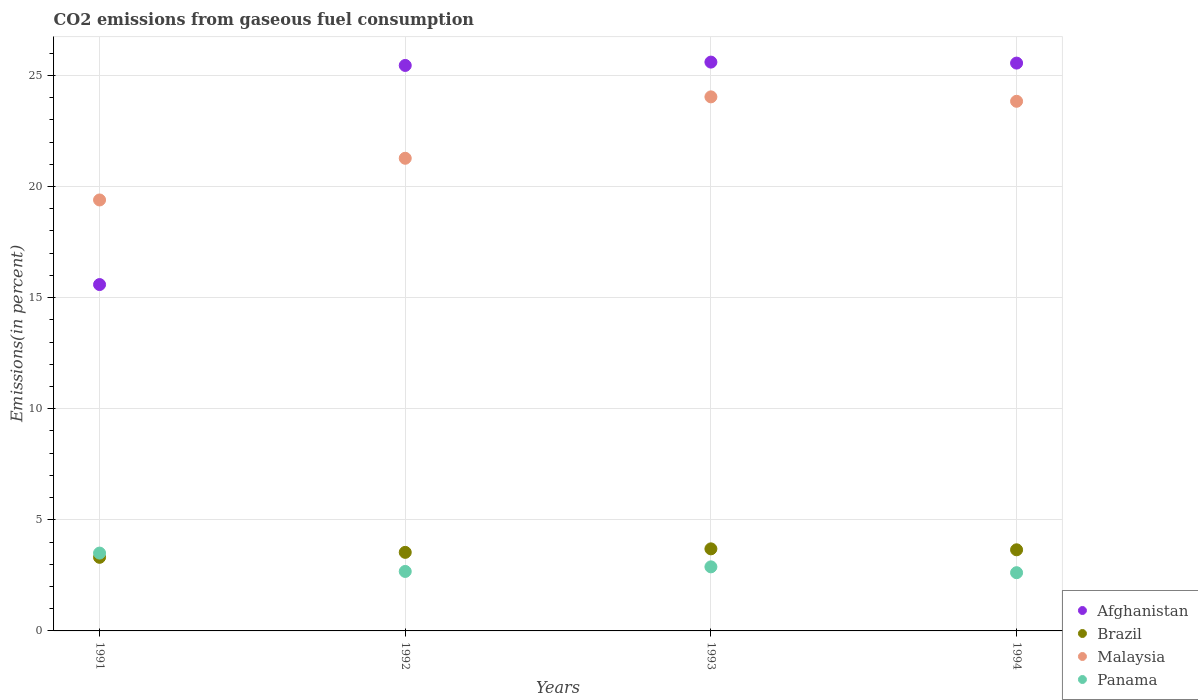What is the total CO2 emitted in Malaysia in 1993?
Offer a very short reply. 24.04. Across all years, what is the maximum total CO2 emitted in Afghanistan?
Offer a very short reply. 25.6. Across all years, what is the minimum total CO2 emitted in Malaysia?
Offer a terse response. 19.4. In which year was the total CO2 emitted in Afghanistan maximum?
Your answer should be compact. 1993. What is the total total CO2 emitted in Afghanistan in the graph?
Your response must be concise. 92.19. What is the difference between the total CO2 emitted in Malaysia in 1992 and that in 1994?
Keep it short and to the point. -2.56. What is the difference between the total CO2 emitted in Panama in 1993 and the total CO2 emitted in Brazil in 1991?
Provide a succinct answer. -0.43. What is the average total CO2 emitted in Malaysia per year?
Your response must be concise. 22.14. In the year 1994, what is the difference between the total CO2 emitted in Malaysia and total CO2 emitted in Brazil?
Offer a very short reply. 20.19. What is the ratio of the total CO2 emitted in Panama in 1992 to that in 1994?
Provide a succinct answer. 1.02. What is the difference between the highest and the second highest total CO2 emitted in Malaysia?
Keep it short and to the point. 0.2. What is the difference between the highest and the lowest total CO2 emitted in Malaysia?
Your answer should be compact. 4.64. In how many years, is the total CO2 emitted in Panama greater than the average total CO2 emitted in Panama taken over all years?
Give a very brief answer. 1. Is it the case that in every year, the sum of the total CO2 emitted in Panama and total CO2 emitted in Afghanistan  is greater than the sum of total CO2 emitted in Malaysia and total CO2 emitted in Brazil?
Provide a short and direct response. Yes. Is it the case that in every year, the sum of the total CO2 emitted in Brazil and total CO2 emitted in Afghanistan  is greater than the total CO2 emitted in Panama?
Make the answer very short. Yes. Is the total CO2 emitted in Panama strictly greater than the total CO2 emitted in Brazil over the years?
Keep it short and to the point. No. Is the total CO2 emitted in Panama strictly less than the total CO2 emitted in Malaysia over the years?
Your answer should be compact. Yes. How many dotlines are there?
Keep it short and to the point. 4. Where does the legend appear in the graph?
Provide a short and direct response. Bottom right. How many legend labels are there?
Provide a succinct answer. 4. How are the legend labels stacked?
Your answer should be very brief. Vertical. What is the title of the graph?
Make the answer very short. CO2 emissions from gaseous fuel consumption. Does "Belize" appear as one of the legend labels in the graph?
Your response must be concise. No. What is the label or title of the Y-axis?
Provide a short and direct response. Emissions(in percent). What is the Emissions(in percent) of Afghanistan in 1991?
Your response must be concise. 15.59. What is the Emissions(in percent) of Brazil in 1991?
Offer a very short reply. 3.31. What is the Emissions(in percent) in Malaysia in 1991?
Offer a terse response. 19.4. What is the Emissions(in percent) in Panama in 1991?
Offer a terse response. 3.5. What is the Emissions(in percent) of Afghanistan in 1992?
Your response must be concise. 25.45. What is the Emissions(in percent) in Brazil in 1992?
Offer a very short reply. 3.54. What is the Emissions(in percent) of Malaysia in 1992?
Provide a short and direct response. 21.27. What is the Emissions(in percent) of Panama in 1992?
Your answer should be compact. 2.68. What is the Emissions(in percent) in Afghanistan in 1993?
Give a very brief answer. 25.6. What is the Emissions(in percent) in Brazil in 1993?
Offer a terse response. 3.69. What is the Emissions(in percent) in Malaysia in 1993?
Make the answer very short. 24.04. What is the Emissions(in percent) in Panama in 1993?
Provide a succinct answer. 2.88. What is the Emissions(in percent) of Afghanistan in 1994?
Ensure brevity in your answer.  25.56. What is the Emissions(in percent) of Brazil in 1994?
Make the answer very short. 3.65. What is the Emissions(in percent) of Malaysia in 1994?
Your answer should be compact. 23.84. What is the Emissions(in percent) of Panama in 1994?
Your answer should be very brief. 2.62. Across all years, what is the maximum Emissions(in percent) of Afghanistan?
Give a very brief answer. 25.6. Across all years, what is the maximum Emissions(in percent) in Brazil?
Keep it short and to the point. 3.69. Across all years, what is the maximum Emissions(in percent) of Malaysia?
Your answer should be very brief. 24.04. Across all years, what is the maximum Emissions(in percent) of Panama?
Provide a short and direct response. 3.5. Across all years, what is the minimum Emissions(in percent) in Afghanistan?
Make the answer very short. 15.59. Across all years, what is the minimum Emissions(in percent) of Brazil?
Your response must be concise. 3.31. Across all years, what is the minimum Emissions(in percent) in Malaysia?
Your answer should be compact. 19.4. Across all years, what is the minimum Emissions(in percent) in Panama?
Offer a terse response. 2.62. What is the total Emissions(in percent) of Afghanistan in the graph?
Provide a short and direct response. 92.19. What is the total Emissions(in percent) of Brazil in the graph?
Keep it short and to the point. 14.19. What is the total Emissions(in percent) in Malaysia in the graph?
Provide a succinct answer. 88.54. What is the total Emissions(in percent) in Panama in the graph?
Offer a terse response. 11.68. What is the difference between the Emissions(in percent) in Afghanistan in 1991 and that in 1992?
Keep it short and to the point. -9.86. What is the difference between the Emissions(in percent) of Brazil in 1991 and that in 1992?
Offer a very short reply. -0.22. What is the difference between the Emissions(in percent) in Malaysia in 1991 and that in 1992?
Provide a succinct answer. -1.88. What is the difference between the Emissions(in percent) of Panama in 1991 and that in 1992?
Offer a very short reply. 0.83. What is the difference between the Emissions(in percent) of Afghanistan in 1991 and that in 1993?
Keep it short and to the point. -10.01. What is the difference between the Emissions(in percent) in Brazil in 1991 and that in 1993?
Offer a terse response. -0.38. What is the difference between the Emissions(in percent) in Malaysia in 1991 and that in 1993?
Offer a very short reply. -4.64. What is the difference between the Emissions(in percent) of Panama in 1991 and that in 1993?
Provide a succinct answer. 0.62. What is the difference between the Emissions(in percent) of Afghanistan in 1991 and that in 1994?
Provide a succinct answer. -9.97. What is the difference between the Emissions(in percent) of Brazil in 1991 and that in 1994?
Ensure brevity in your answer.  -0.34. What is the difference between the Emissions(in percent) in Malaysia in 1991 and that in 1994?
Keep it short and to the point. -4.44. What is the difference between the Emissions(in percent) in Panama in 1991 and that in 1994?
Give a very brief answer. 0.88. What is the difference between the Emissions(in percent) of Afghanistan in 1992 and that in 1993?
Your answer should be very brief. -0.15. What is the difference between the Emissions(in percent) of Brazil in 1992 and that in 1993?
Give a very brief answer. -0.16. What is the difference between the Emissions(in percent) of Malaysia in 1992 and that in 1993?
Your answer should be compact. -2.76. What is the difference between the Emissions(in percent) in Panama in 1992 and that in 1993?
Your answer should be compact. -0.21. What is the difference between the Emissions(in percent) of Afghanistan in 1992 and that in 1994?
Offer a terse response. -0.11. What is the difference between the Emissions(in percent) of Brazil in 1992 and that in 1994?
Offer a very short reply. -0.12. What is the difference between the Emissions(in percent) in Malaysia in 1992 and that in 1994?
Keep it short and to the point. -2.56. What is the difference between the Emissions(in percent) in Panama in 1992 and that in 1994?
Your answer should be very brief. 0.06. What is the difference between the Emissions(in percent) of Afghanistan in 1993 and that in 1994?
Provide a short and direct response. 0.04. What is the difference between the Emissions(in percent) in Brazil in 1993 and that in 1994?
Your answer should be very brief. 0.04. What is the difference between the Emissions(in percent) in Malaysia in 1993 and that in 1994?
Offer a terse response. 0.2. What is the difference between the Emissions(in percent) in Panama in 1993 and that in 1994?
Provide a short and direct response. 0.26. What is the difference between the Emissions(in percent) in Afghanistan in 1991 and the Emissions(in percent) in Brazil in 1992?
Make the answer very short. 12.05. What is the difference between the Emissions(in percent) of Afghanistan in 1991 and the Emissions(in percent) of Malaysia in 1992?
Ensure brevity in your answer.  -5.68. What is the difference between the Emissions(in percent) in Afghanistan in 1991 and the Emissions(in percent) in Panama in 1992?
Offer a very short reply. 12.91. What is the difference between the Emissions(in percent) in Brazil in 1991 and the Emissions(in percent) in Malaysia in 1992?
Make the answer very short. -17.96. What is the difference between the Emissions(in percent) of Brazil in 1991 and the Emissions(in percent) of Panama in 1992?
Your answer should be compact. 0.64. What is the difference between the Emissions(in percent) in Malaysia in 1991 and the Emissions(in percent) in Panama in 1992?
Give a very brief answer. 16.72. What is the difference between the Emissions(in percent) of Afghanistan in 1991 and the Emissions(in percent) of Brazil in 1993?
Ensure brevity in your answer.  11.89. What is the difference between the Emissions(in percent) of Afghanistan in 1991 and the Emissions(in percent) of Malaysia in 1993?
Provide a succinct answer. -8.45. What is the difference between the Emissions(in percent) of Afghanistan in 1991 and the Emissions(in percent) of Panama in 1993?
Your answer should be very brief. 12.7. What is the difference between the Emissions(in percent) in Brazil in 1991 and the Emissions(in percent) in Malaysia in 1993?
Make the answer very short. -20.72. What is the difference between the Emissions(in percent) in Brazil in 1991 and the Emissions(in percent) in Panama in 1993?
Your answer should be compact. 0.43. What is the difference between the Emissions(in percent) of Malaysia in 1991 and the Emissions(in percent) of Panama in 1993?
Your response must be concise. 16.51. What is the difference between the Emissions(in percent) in Afghanistan in 1991 and the Emissions(in percent) in Brazil in 1994?
Offer a terse response. 11.94. What is the difference between the Emissions(in percent) of Afghanistan in 1991 and the Emissions(in percent) of Malaysia in 1994?
Offer a terse response. -8.25. What is the difference between the Emissions(in percent) in Afghanistan in 1991 and the Emissions(in percent) in Panama in 1994?
Your response must be concise. 12.97. What is the difference between the Emissions(in percent) of Brazil in 1991 and the Emissions(in percent) of Malaysia in 1994?
Make the answer very short. -20.52. What is the difference between the Emissions(in percent) of Brazil in 1991 and the Emissions(in percent) of Panama in 1994?
Give a very brief answer. 0.69. What is the difference between the Emissions(in percent) of Malaysia in 1991 and the Emissions(in percent) of Panama in 1994?
Provide a short and direct response. 16.78. What is the difference between the Emissions(in percent) of Afghanistan in 1992 and the Emissions(in percent) of Brazil in 1993?
Provide a succinct answer. 21.76. What is the difference between the Emissions(in percent) of Afghanistan in 1992 and the Emissions(in percent) of Malaysia in 1993?
Your answer should be very brief. 1.41. What is the difference between the Emissions(in percent) of Afghanistan in 1992 and the Emissions(in percent) of Panama in 1993?
Give a very brief answer. 22.57. What is the difference between the Emissions(in percent) in Brazil in 1992 and the Emissions(in percent) in Malaysia in 1993?
Give a very brief answer. -20.5. What is the difference between the Emissions(in percent) of Brazil in 1992 and the Emissions(in percent) of Panama in 1993?
Offer a very short reply. 0.65. What is the difference between the Emissions(in percent) of Malaysia in 1992 and the Emissions(in percent) of Panama in 1993?
Keep it short and to the point. 18.39. What is the difference between the Emissions(in percent) in Afghanistan in 1992 and the Emissions(in percent) in Brazil in 1994?
Offer a terse response. 21.8. What is the difference between the Emissions(in percent) of Afghanistan in 1992 and the Emissions(in percent) of Malaysia in 1994?
Provide a short and direct response. 1.61. What is the difference between the Emissions(in percent) of Afghanistan in 1992 and the Emissions(in percent) of Panama in 1994?
Make the answer very short. 22.83. What is the difference between the Emissions(in percent) in Brazil in 1992 and the Emissions(in percent) in Malaysia in 1994?
Offer a terse response. -20.3. What is the difference between the Emissions(in percent) of Brazil in 1992 and the Emissions(in percent) of Panama in 1994?
Your response must be concise. 0.92. What is the difference between the Emissions(in percent) in Malaysia in 1992 and the Emissions(in percent) in Panama in 1994?
Your answer should be compact. 18.65. What is the difference between the Emissions(in percent) in Afghanistan in 1993 and the Emissions(in percent) in Brazil in 1994?
Provide a short and direct response. 21.95. What is the difference between the Emissions(in percent) of Afghanistan in 1993 and the Emissions(in percent) of Malaysia in 1994?
Provide a succinct answer. 1.76. What is the difference between the Emissions(in percent) of Afghanistan in 1993 and the Emissions(in percent) of Panama in 1994?
Provide a short and direct response. 22.98. What is the difference between the Emissions(in percent) of Brazil in 1993 and the Emissions(in percent) of Malaysia in 1994?
Keep it short and to the point. -20.14. What is the difference between the Emissions(in percent) of Brazil in 1993 and the Emissions(in percent) of Panama in 1994?
Ensure brevity in your answer.  1.07. What is the difference between the Emissions(in percent) in Malaysia in 1993 and the Emissions(in percent) in Panama in 1994?
Your response must be concise. 21.41. What is the average Emissions(in percent) in Afghanistan per year?
Your answer should be very brief. 23.05. What is the average Emissions(in percent) in Brazil per year?
Offer a very short reply. 3.55. What is the average Emissions(in percent) of Malaysia per year?
Your answer should be compact. 22.14. What is the average Emissions(in percent) in Panama per year?
Provide a short and direct response. 2.92. In the year 1991, what is the difference between the Emissions(in percent) of Afghanistan and Emissions(in percent) of Brazil?
Your response must be concise. 12.28. In the year 1991, what is the difference between the Emissions(in percent) of Afghanistan and Emissions(in percent) of Malaysia?
Your answer should be compact. -3.81. In the year 1991, what is the difference between the Emissions(in percent) in Afghanistan and Emissions(in percent) in Panama?
Your response must be concise. 12.09. In the year 1991, what is the difference between the Emissions(in percent) of Brazil and Emissions(in percent) of Malaysia?
Ensure brevity in your answer.  -16.08. In the year 1991, what is the difference between the Emissions(in percent) in Brazil and Emissions(in percent) in Panama?
Offer a very short reply. -0.19. In the year 1991, what is the difference between the Emissions(in percent) in Malaysia and Emissions(in percent) in Panama?
Your answer should be compact. 15.89. In the year 1992, what is the difference between the Emissions(in percent) in Afghanistan and Emissions(in percent) in Brazil?
Keep it short and to the point. 21.91. In the year 1992, what is the difference between the Emissions(in percent) of Afghanistan and Emissions(in percent) of Malaysia?
Ensure brevity in your answer.  4.18. In the year 1992, what is the difference between the Emissions(in percent) in Afghanistan and Emissions(in percent) in Panama?
Provide a short and direct response. 22.77. In the year 1992, what is the difference between the Emissions(in percent) in Brazil and Emissions(in percent) in Malaysia?
Offer a very short reply. -17.74. In the year 1992, what is the difference between the Emissions(in percent) of Brazil and Emissions(in percent) of Panama?
Keep it short and to the point. 0.86. In the year 1992, what is the difference between the Emissions(in percent) in Malaysia and Emissions(in percent) in Panama?
Offer a very short reply. 18.59. In the year 1993, what is the difference between the Emissions(in percent) of Afghanistan and Emissions(in percent) of Brazil?
Ensure brevity in your answer.  21.91. In the year 1993, what is the difference between the Emissions(in percent) in Afghanistan and Emissions(in percent) in Malaysia?
Your answer should be very brief. 1.56. In the year 1993, what is the difference between the Emissions(in percent) in Afghanistan and Emissions(in percent) in Panama?
Your response must be concise. 22.72. In the year 1993, what is the difference between the Emissions(in percent) in Brazil and Emissions(in percent) in Malaysia?
Your answer should be compact. -20.34. In the year 1993, what is the difference between the Emissions(in percent) of Brazil and Emissions(in percent) of Panama?
Give a very brief answer. 0.81. In the year 1993, what is the difference between the Emissions(in percent) of Malaysia and Emissions(in percent) of Panama?
Provide a short and direct response. 21.15. In the year 1994, what is the difference between the Emissions(in percent) of Afghanistan and Emissions(in percent) of Brazil?
Your response must be concise. 21.9. In the year 1994, what is the difference between the Emissions(in percent) of Afghanistan and Emissions(in percent) of Malaysia?
Your answer should be compact. 1.72. In the year 1994, what is the difference between the Emissions(in percent) in Afghanistan and Emissions(in percent) in Panama?
Offer a terse response. 22.94. In the year 1994, what is the difference between the Emissions(in percent) in Brazil and Emissions(in percent) in Malaysia?
Give a very brief answer. -20.19. In the year 1994, what is the difference between the Emissions(in percent) in Brazil and Emissions(in percent) in Panama?
Your answer should be very brief. 1.03. In the year 1994, what is the difference between the Emissions(in percent) in Malaysia and Emissions(in percent) in Panama?
Offer a terse response. 21.22. What is the ratio of the Emissions(in percent) of Afghanistan in 1991 to that in 1992?
Your answer should be very brief. 0.61. What is the ratio of the Emissions(in percent) in Brazil in 1991 to that in 1992?
Offer a very short reply. 0.94. What is the ratio of the Emissions(in percent) of Malaysia in 1991 to that in 1992?
Your answer should be very brief. 0.91. What is the ratio of the Emissions(in percent) in Panama in 1991 to that in 1992?
Your answer should be very brief. 1.31. What is the ratio of the Emissions(in percent) of Afghanistan in 1991 to that in 1993?
Ensure brevity in your answer.  0.61. What is the ratio of the Emissions(in percent) in Brazil in 1991 to that in 1993?
Your answer should be very brief. 0.9. What is the ratio of the Emissions(in percent) of Malaysia in 1991 to that in 1993?
Give a very brief answer. 0.81. What is the ratio of the Emissions(in percent) of Panama in 1991 to that in 1993?
Offer a very short reply. 1.21. What is the ratio of the Emissions(in percent) in Afghanistan in 1991 to that in 1994?
Your answer should be very brief. 0.61. What is the ratio of the Emissions(in percent) in Brazil in 1991 to that in 1994?
Offer a very short reply. 0.91. What is the ratio of the Emissions(in percent) of Malaysia in 1991 to that in 1994?
Offer a very short reply. 0.81. What is the ratio of the Emissions(in percent) of Panama in 1991 to that in 1994?
Provide a short and direct response. 1.34. What is the ratio of the Emissions(in percent) of Brazil in 1992 to that in 1993?
Your answer should be compact. 0.96. What is the ratio of the Emissions(in percent) of Malaysia in 1992 to that in 1993?
Provide a succinct answer. 0.89. What is the ratio of the Emissions(in percent) in Panama in 1992 to that in 1993?
Keep it short and to the point. 0.93. What is the ratio of the Emissions(in percent) of Afghanistan in 1992 to that in 1994?
Your answer should be very brief. 1. What is the ratio of the Emissions(in percent) of Brazil in 1992 to that in 1994?
Make the answer very short. 0.97. What is the ratio of the Emissions(in percent) in Malaysia in 1992 to that in 1994?
Offer a terse response. 0.89. What is the ratio of the Emissions(in percent) of Panama in 1992 to that in 1994?
Keep it short and to the point. 1.02. What is the ratio of the Emissions(in percent) in Brazil in 1993 to that in 1994?
Provide a short and direct response. 1.01. What is the ratio of the Emissions(in percent) in Malaysia in 1993 to that in 1994?
Keep it short and to the point. 1.01. What is the ratio of the Emissions(in percent) in Panama in 1993 to that in 1994?
Keep it short and to the point. 1.1. What is the difference between the highest and the second highest Emissions(in percent) in Afghanistan?
Your response must be concise. 0.04. What is the difference between the highest and the second highest Emissions(in percent) in Brazil?
Provide a short and direct response. 0.04. What is the difference between the highest and the second highest Emissions(in percent) in Malaysia?
Offer a very short reply. 0.2. What is the difference between the highest and the second highest Emissions(in percent) of Panama?
Ensure brevity in your answer.  0.62. What is the difference between the highest and the lowest Emissions(in percent) in Afghanistan?
Offer a terse response. 10.01. What is the difference between the highest and the lowest Emissions(in percent) of Brazil?
Give a very brief answer. 0.38. What is the difference between the highest and the lowest Emissions(in percent) in Malaysia?
Keep it short and to the point. 4.64. What is the difference between the highest and the lowest Emissions(in percent) of Panama?
Ensure brevity in your answer.  0.88. 